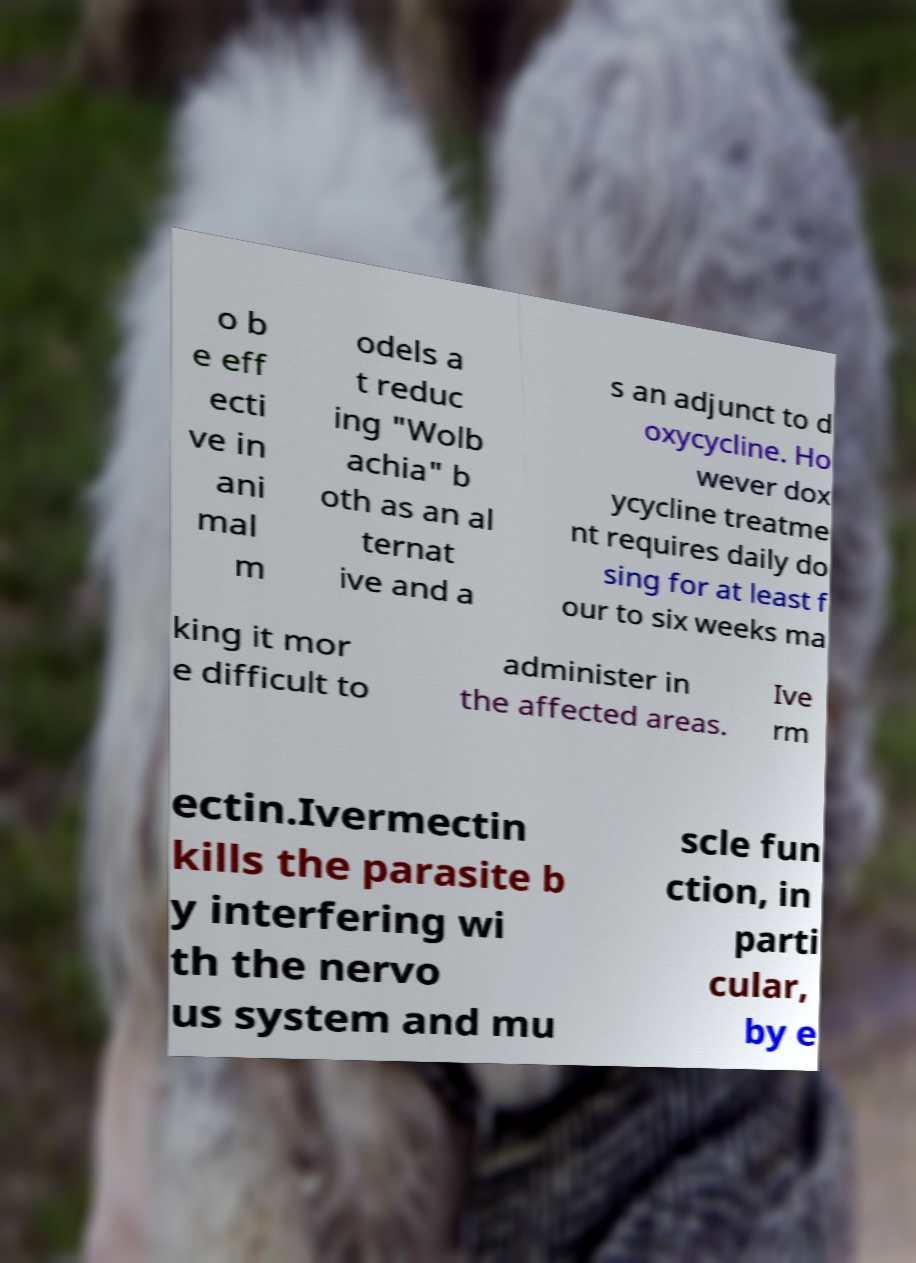Can you read and provide the text displayed in the image?This photo seems to have some interesting text. Can you extract and type it out for me? o b e eff ecti ve in ani mal m odels a t reduc ing "Wolb achia" b oth as an al ternat ive and a s an adjunct to d oxycycline. Ho wever dox ycycline treatme nt requires daily do sing for at least f our to six weeks ma king it mor e difficult to administer in the affected areas. Ive rm ectin.Ivermectin kills the parasite b y interfering wi th the nervo us system and mu scle fun ction, in parti cular, by e 